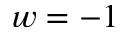<formula> <loc_0><loc_0><loc_500><loc_500>w = - 1</formula> 